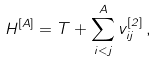<formula> <loc_0><loc_0><loc_500><loc_500>H ^ { [ A ] } = T + \sum _ { i < j } ^ { A } v ^ { [ 2 ] } _ { i j } \, ,</formula> 